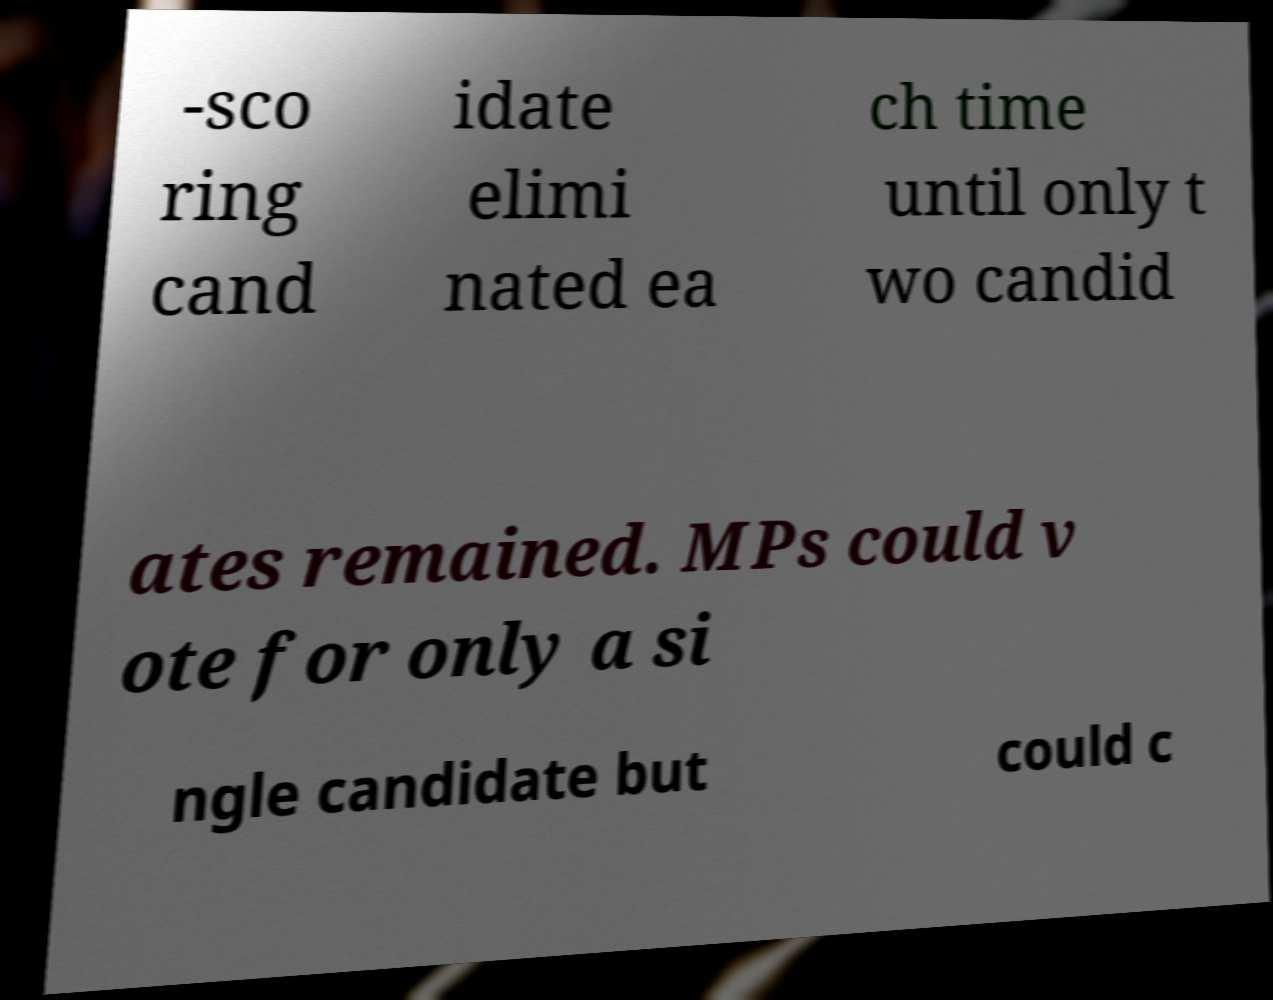Can you read and provide the text displayed in the image?This photo seems to have some interesting text. Can you extract and type it out for me? -sco ring cand idate elimi nated ea ch time until only t wo candid ates remained. MPs could v ote for only a si ngle candidate but could c 